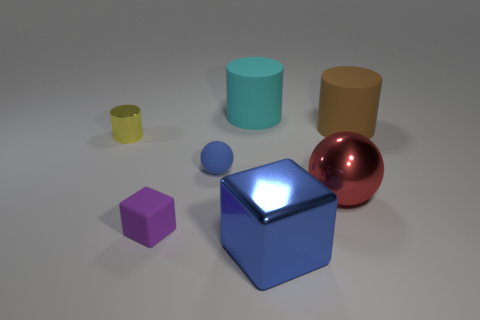Add 1 red objects. How many objects exist? 8 Subtract all cyan cylinders. How many cylinders are left? 2 Subtract all small metallic cylinders. How many cylinders are left? 2 Subtract 1 cubes. How many cubes are left? 1 Subtract all brown cylinders. How many blue cubes are left? 1 Subtract all big cyan shiny things. Subtract all brown rubber objects. How many objects are left? 6 Add 6 tiny purple cubes. How many tiny purple cubes are left? 7 Add 7 small objects. How many small objects exist? 10 Subtract 1 brown cylinders. How many objects are left? 6 Subtract all cubes. How many objects are left? 5 